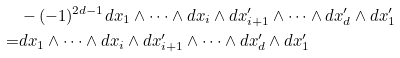Convert formula to latex. <formula><loc_0><loc_0><loc_500><loc_500>& - ( - 1 ) ^ { 2 d - 1 } d x _ { 1 } \wedge \cdots \wedge d x _ { i } \wedge d x _ { i + 1 } ^ { \prime } \wedge \cdots \wedge d x _ { d } ^ { \prime } \wedge d x _ { 1 } ^ { \prime } \\ = & d x _ { 1 } \wedge \cdots \wedge d x _ { i } \wedge d x _ { i + 1 } ^ { \prime } \wedge \cdots \wedge d x _ { d } ^ { \prime } \wedge d x _ { 1 } ^ { \prime }</formula> 